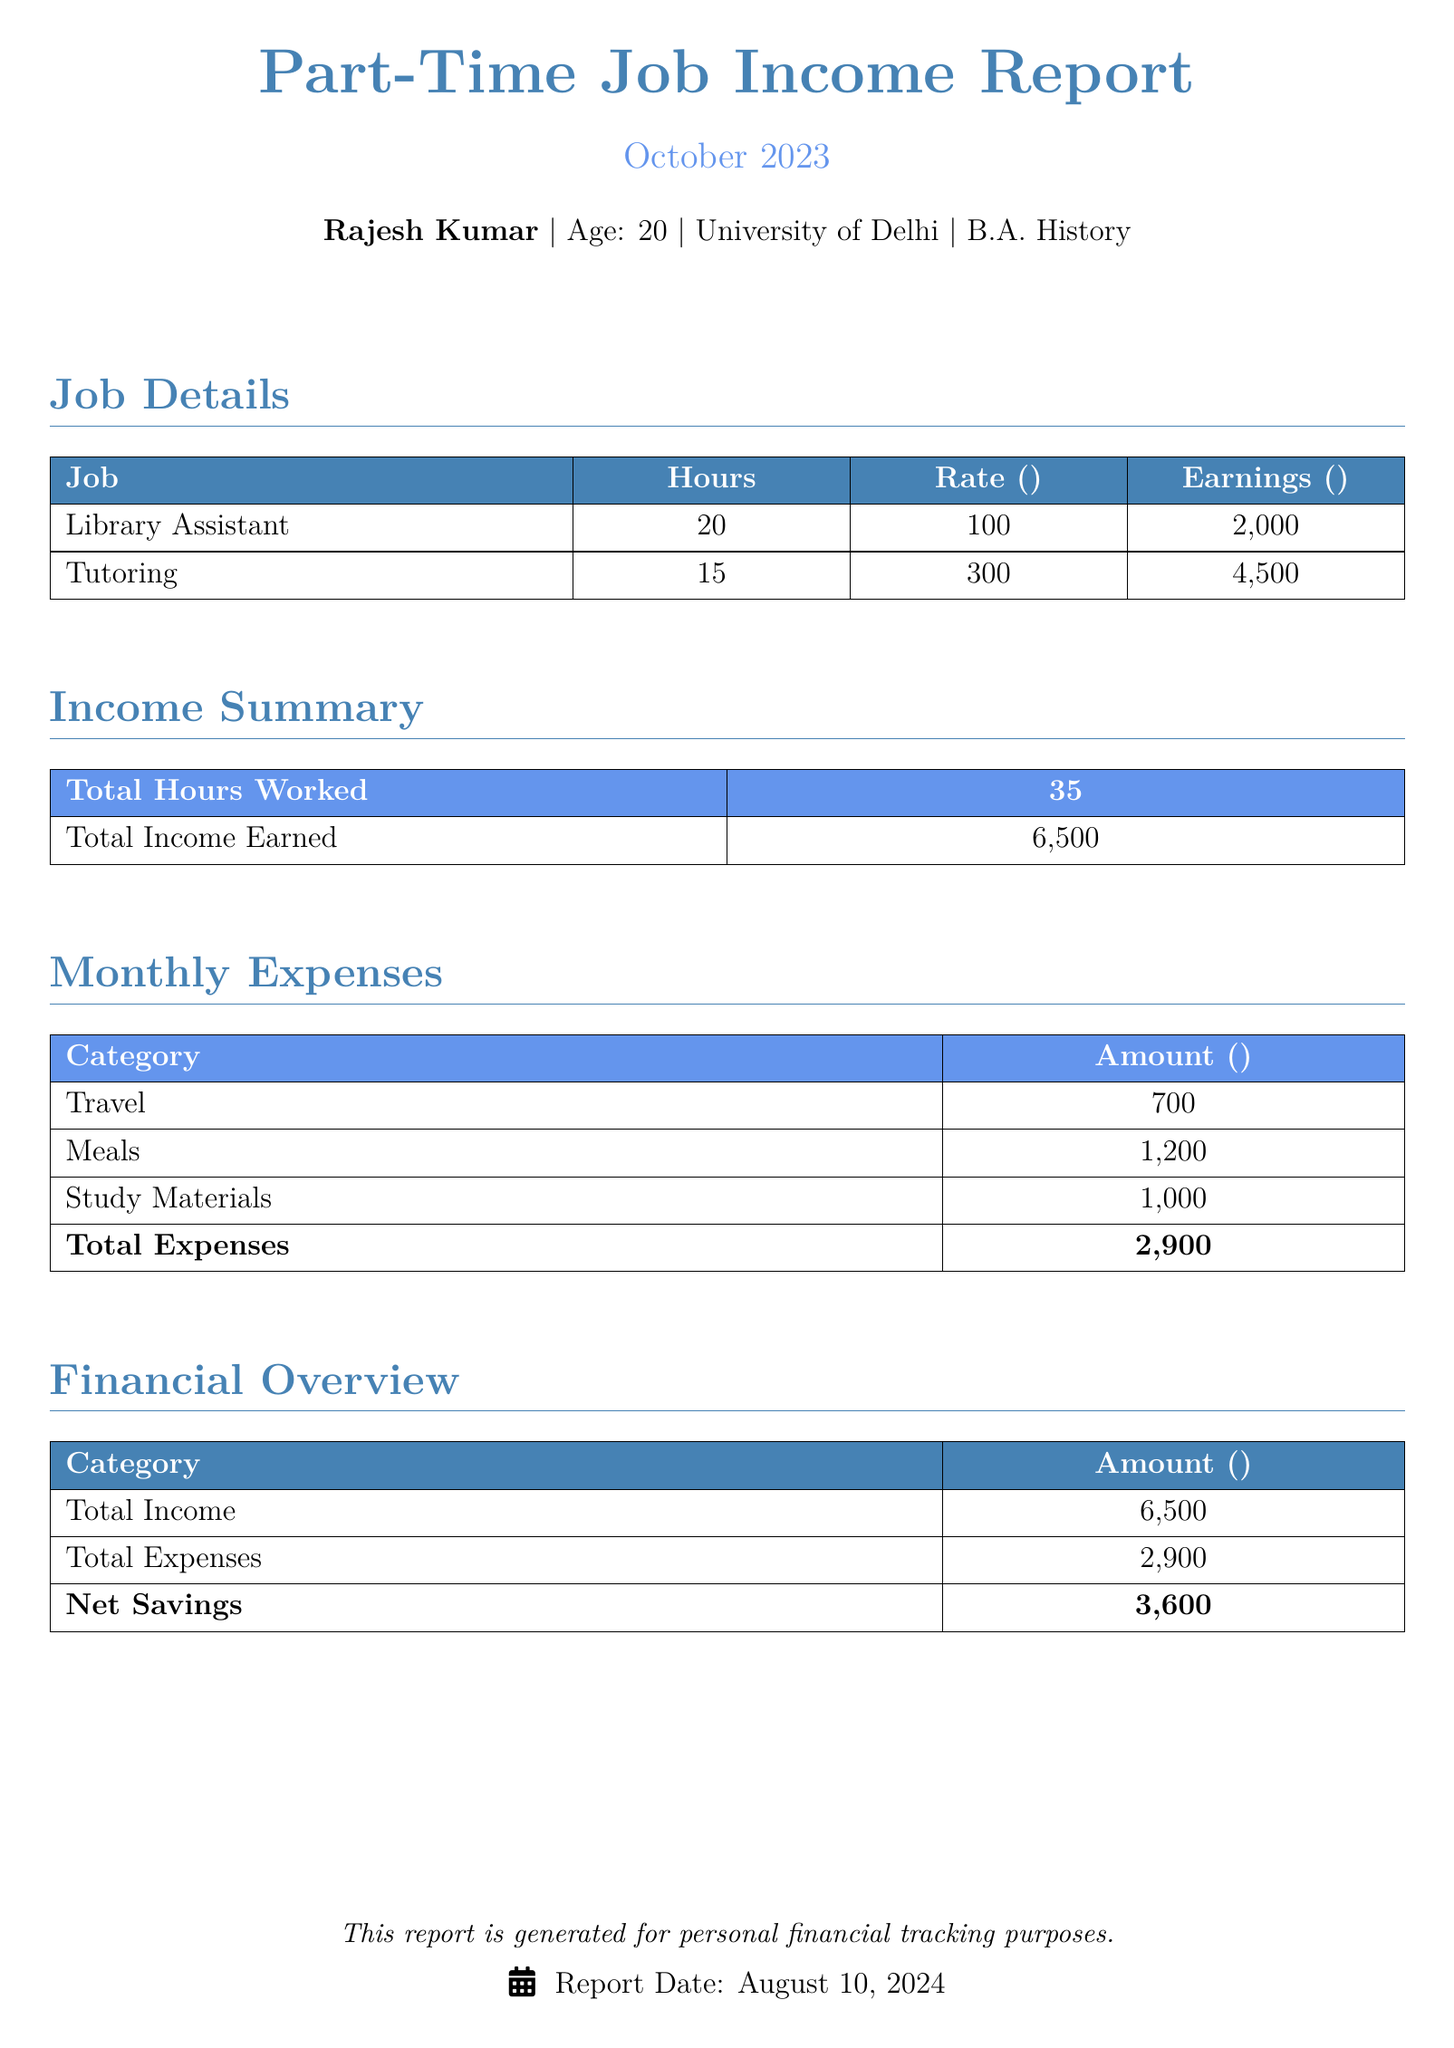What is the total income earned? The total income earned is listed in the Income Summary section of the document.
Answer: ₹6,500 How many hours did Rajesh work as a Library Assistant? The hours worked as a Library Assistant are specified in the Job Details table.
Answer: 20 What are the total expenses? The total expenses are calculated from the Monthly Expenses table.
Answer: ₹2,900 What is Rajesh's job title for the tutoring role? The job title for the tutoring role is mentioned in the Job Details section.
Answer: Tutoring What is the net savings for the month? The net savings are derived from subtracting total expenses from total income in the Financial Overview.
Answer: ₹3,600 How much did Rajesh earn from tutoring? The earnings from tutoring are provided in the Job Details table.
Answer: ₹4,500 What is the amount spent on travel? The amount spent on travel is specified in the Monthly Expenses table.
Answer: ₹700 How many total hours were worked in October 2023? The total hours worked are summed up in the Income Summary section.
Answer: 35 What is the age of Rajesh Kumar? Rajesh's age is listed in the introductory section of the document.
Answer: 20 